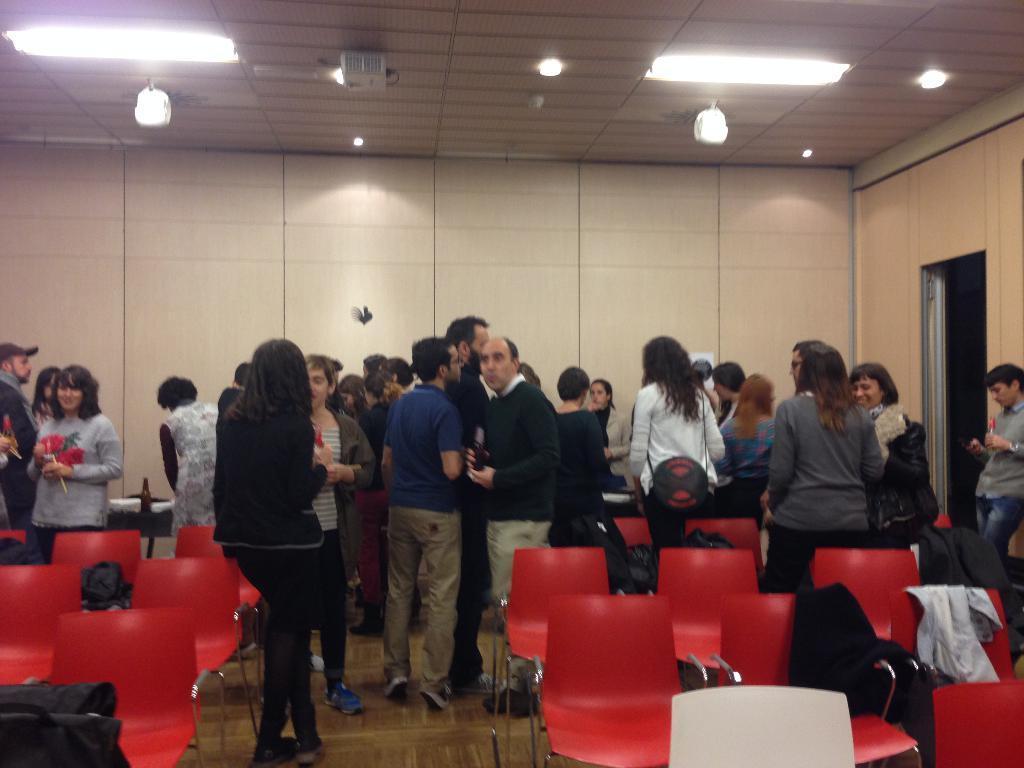In one or two sentences, can you explain what this image depicts? In the image there are many people standing and discussing in a room and around them there are many empty chairs and there are some jackets kept on the chairs, in the background there is a wall and on the right side there is a door. 